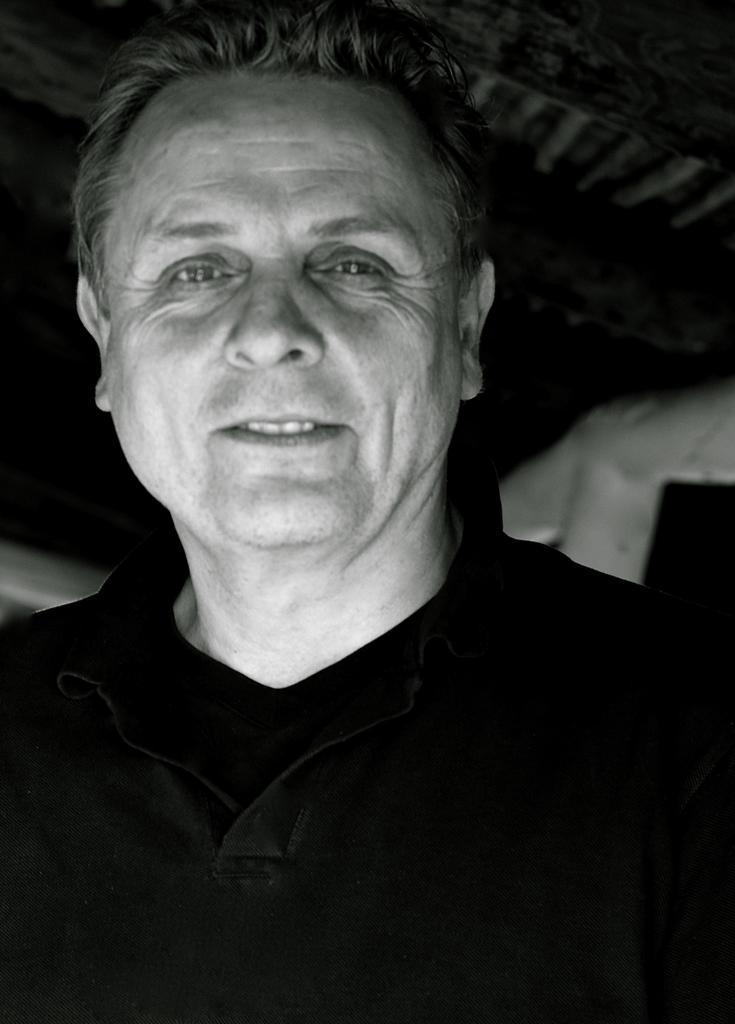In one or two sentences, can you explain what this image depicts? It is a black and white image, there is a man, he is smiling and posing for the photo and the background of the man is blur. 